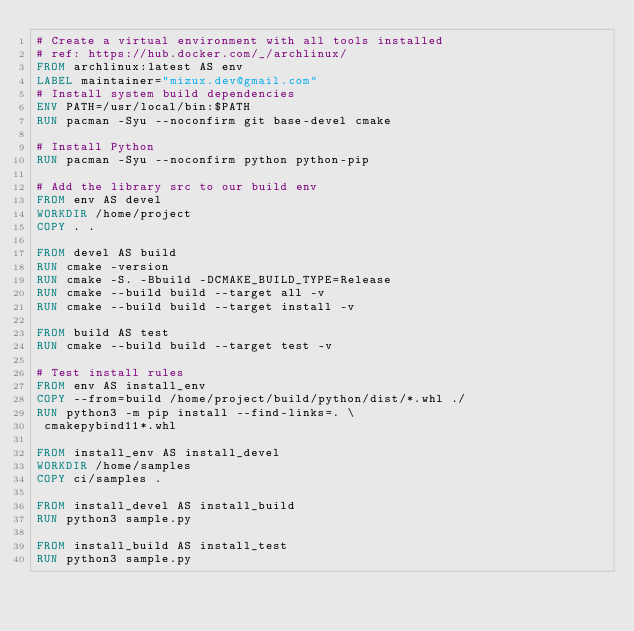Convert code to text. <code><loc_0><loc_0><loc_500><loc_500><_Dockerfile_># Create a virtual environment with all tools installed
# ref: https://hub.docker.com/_/archlinux/
FROM archlinux:latest AS env
LABEL maintainer="mizux.dev@gmail.com"
# Install system build dependencies
ENV PATH=/usr/local/bin:$PATH
RUN pacman -Syu --noconfirm git base-devel cmake

# Install Python
RUN pacman -Syu --noconfirm python python-pip

# Add the library src to our build env
FROM env AS devel
WORKDIR /home/project
COPY . .

FROM devel AS build
RUN cmake -version
RUN cmake -S. -Bbuild -DCMAKE_BUILD_TYPE=Release
RUN cmake --build build --target all -v
RUN cmake --build build --target install -v

FROM build AS test
RUN cmake --build build --target test -v

# Test install rules
FROM env AS install_env
COPY --from=build /home/project/build/python/dist/*.whl ./
RUN python3 -m pip install --find-links=. \
 cmakepybind11*.whl

FROM install_env AS install_devel
WORKDIR /home/samples
COPY ci/samples .

FROM install_devel AS install_build
RUN python3 sample.py

FROM install_build AS install_test
RUN python3 sample.py
</code> 